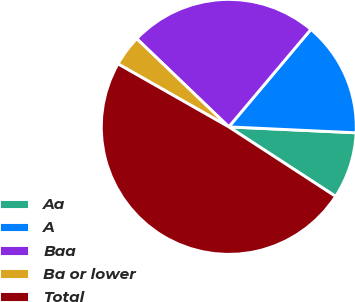<chart> <loc_0><loc_0><loc_500><loc_500><pie_chart><fcel>Aa<fcel>A<fcel>Baa<fcel>Ba or lower<fcel>Total<nl><fcel>8.44%<fcel>14.6%<fcel>23.98%<fcel>3.93%<fcel>49.05%<nl></chart> 